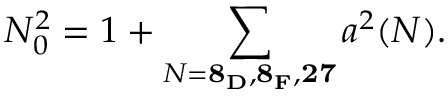Convert formula to latex. <formula><loc_0><loc_0><loc_500><loc_500>N _ { 0 } ^ { 2 } = 1 + \sum _ { N = { 8 _ { D } , 8 _ { F } , 2 7 } } a ^ { 2 } ( N ) .</formula> 